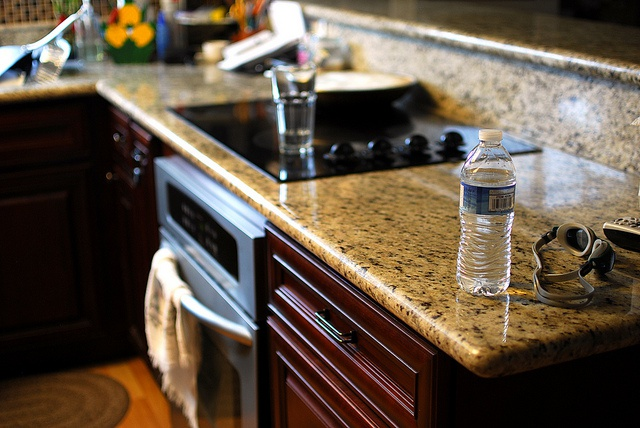Describe the objects in this image and their specific colors. I can see oven in black, white, gray, and maroon tones, bottle in black, darkgray, gray, and tan tones, bowl in black, ivory, and tan tones, cup in black, gray, lightgray, and darkgray tones, and bottle in black, navy, blue, and gray tones in this image. 